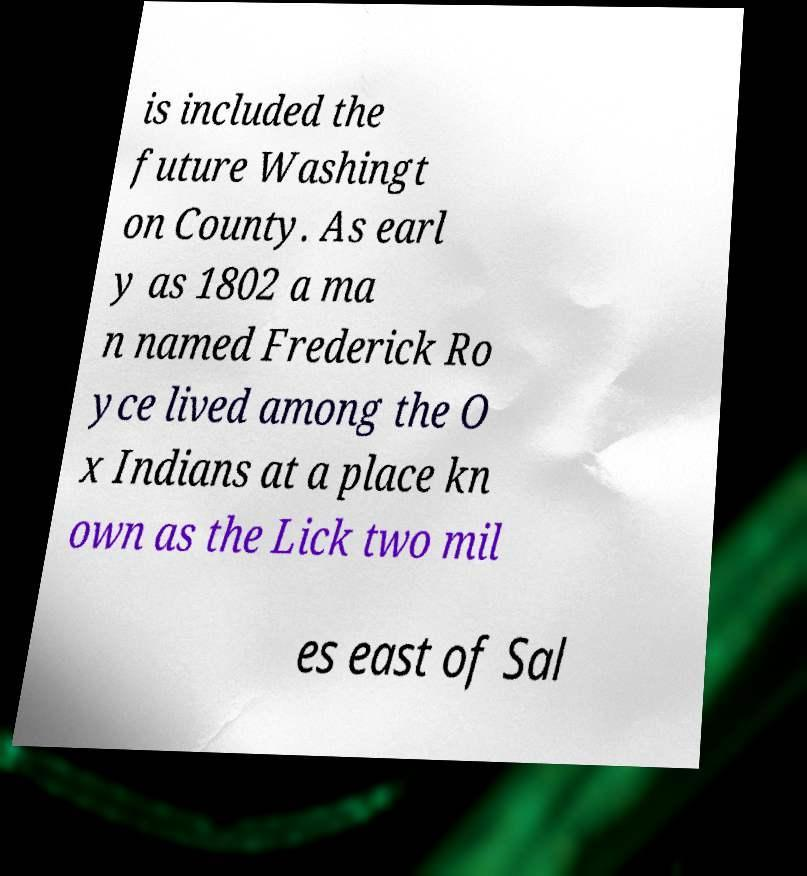Can you accurately transcribe the text from the provided image for me? is included the future Washingt on County. As earl y as 1802 a ma n named Frederick Ro yce lived among the O x Indians at a place kn own as the Lick two mil es east of Sal 